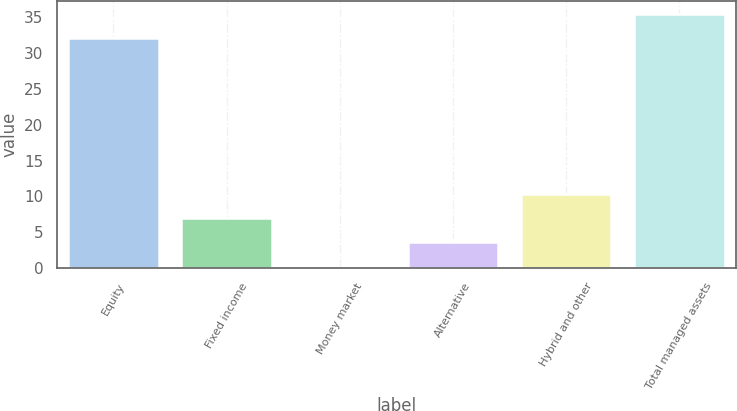Convert chart. <chart><loc_0><loc_0><loc_500><loc_500><bar_chart><fcel>Equity<fcel>Fixed income<fcel>Money market<fcel>Alternative<fcel>Hybrid and other<fcel>Total managed assets<nl><fcel>32.1<fcel>6.96<fcel>0.2<fcel>3.58<fcel>10.34<fcel>35.48<nl></chart> 